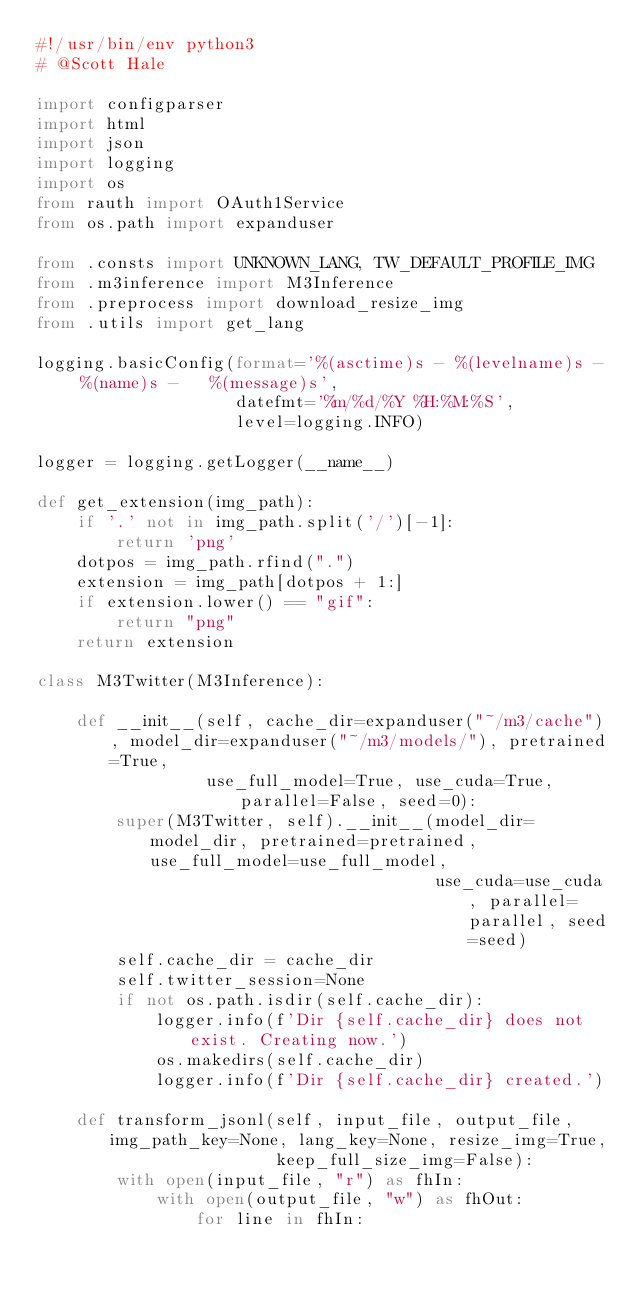<code> <loc_0><loc_0><loc_500><loc_500><_Python_>#!/usr/bin/env python3
# @Scott Hale

import configparser
import html
import json
import logging
import os
from rauth import OAuth1Service
from os.path import expanduser

from .consts import UNKNOWN_LANG, TW_DEFAULT_PROFILE_IMG
from .m3inference import M3Inference
from .preprocess import download_resize_img
from .utils import get_lang

logging.basicConfig(format='%(asctime)s - %(levelname)s - %(name)s -   %(message)s',
                    datefmt='%m/%d/%Y %H:%M:%S',
                    level=logging.INFO)

logger = logging.getLogger(__name__)

def get_extension(img_path):
    if '.' not in img_path.split('/')[-1]:
        return 'png'
    dotpos = img_path.rfind(".")
    extension = img_path[dotpos + 1:]
    if extension.lower() == "gif":
        return "png"
    return extension

class M3Twitter(M3Inference):

    def __init__(self, cache_dir=expanduser("~/m3/cache"), model_dir=expanduser("~/m3/models/"), pretrained=True,
                 use_full_model=True, use_cuda=True, parallel=False, seed=0):
        super(M3Twitter, self).__init__(model_dir=model_dir, pretrained=pretrained, use_full_model=use_full_model,
                                        use_cuda=use_cuda, parallel=parallel, seed=seed)
        self.cache_dir = cache_dir
        self.twitter_session=None
        if not os.path.isdir(self.cache_dir):
            logger.info(f'Dir {self.cache_dir} does not exist. Creating now.')
            os.makedirs(self.cache_dir)
            logger.info(f'Dir {self.cache_dir} created.')

    def transform_jsonl(self, input_file, output_file, img_path_key=None, lang_key=None, resize_img=True,
                        keep_full_size_img=False):
        with open(input_file, "r") as fhIn:
            with open(output_file, "w") as fhOut:
                for line in fhIn:</code> 